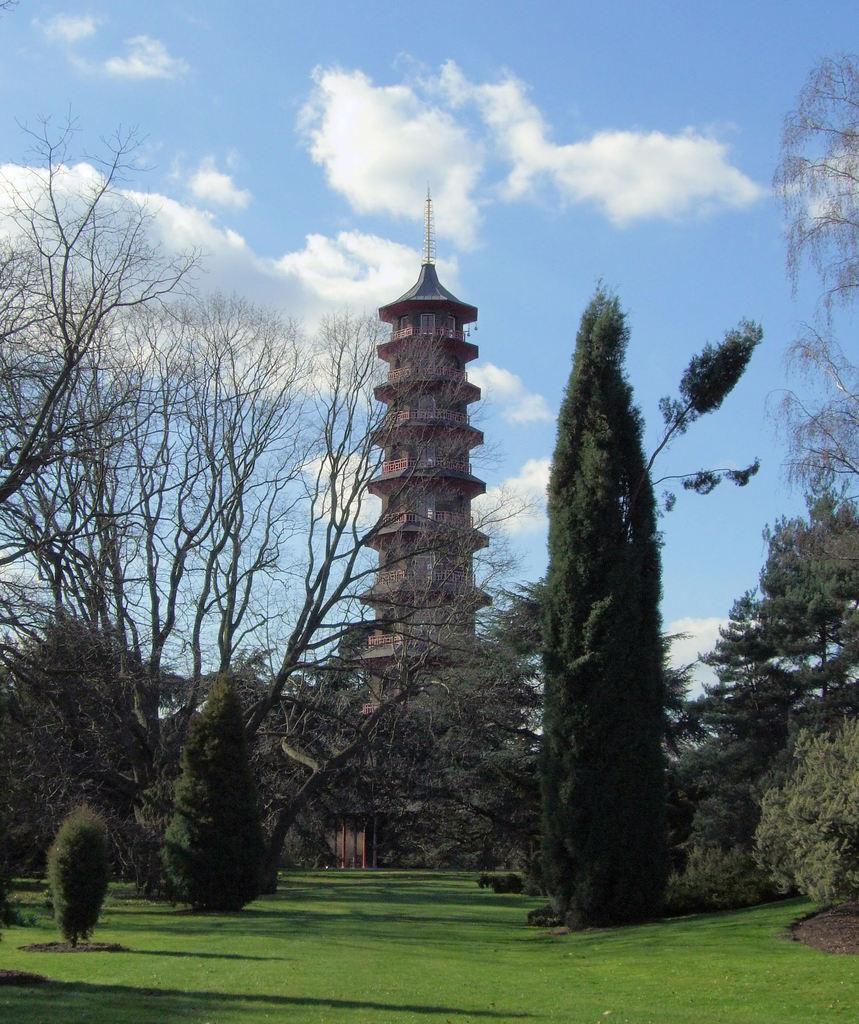What is the main structure in the foreground of the image? There is a tower in the foreground of the image. What type of vegetation can be seen in the image? There are trees and grass visible in the image. What is visible in the sky in the image? There are clouds visible in the image. What part of the natural environment is visible in the image? The sky is visible in the image. What type of mint is growing near the tower in the image? There is no mint visible in the image; the vegetation consists of trees and grass. 